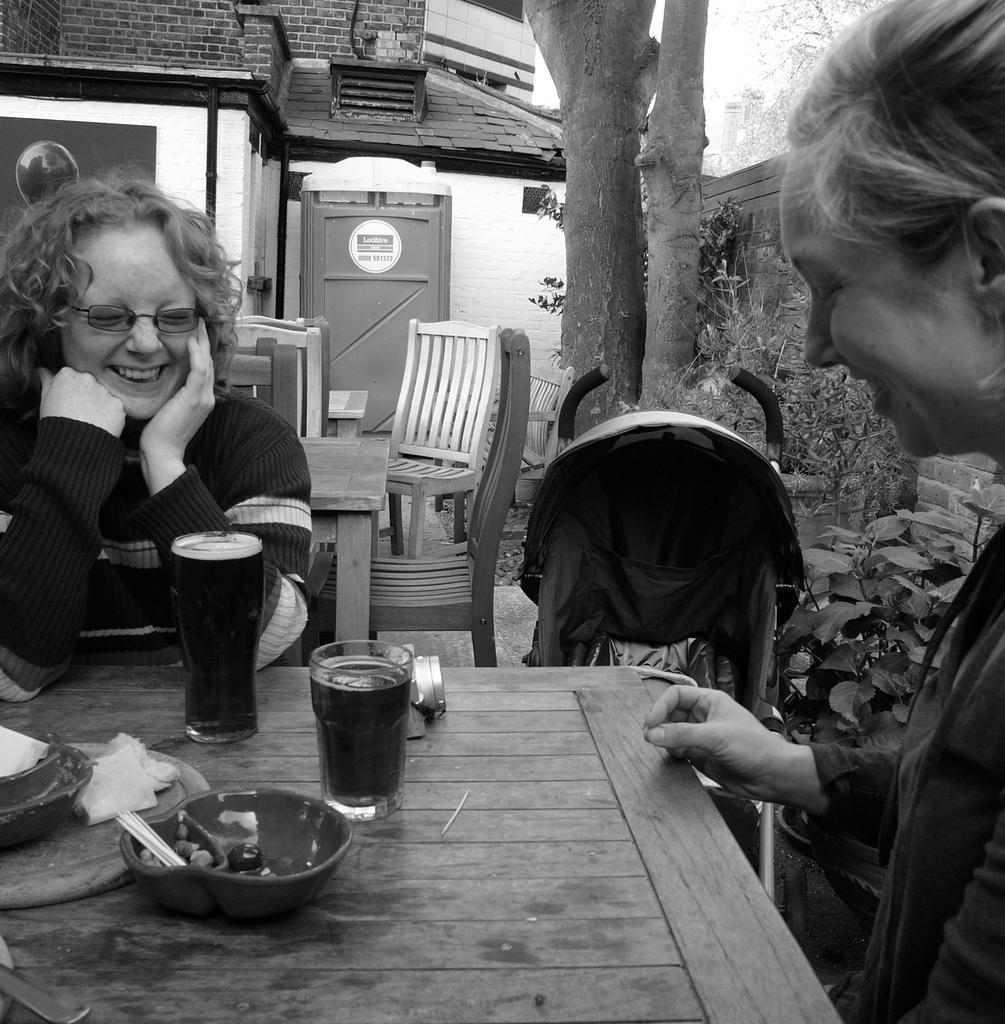How would you summarize this image in a sentence or two? In this picture we can see two women sitting on chair and in front of them there is table and on table we can see glass with drink in it,bowl, tissue paper and in background we can see house with door, tree, wall. 